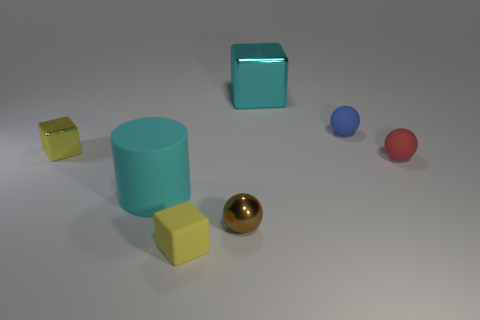Add 2 large cyan objects. How many objects exist? 9 Subtract all small cubes. How many cubes are left? 1 Subtract all green cylinders. How many yellow blocks are left? 2 Subtract all cylinders. How many objects are left? 6 Subtract all yellow cubes. How many cubes are left? 1 Subtract 0 brown cubes. How many objects are left? 7 Subtract 1 cubes. How many cubes are left? 2 Subtract all red cylinders. Subtract all gray balls. How many cylinders are left? 1 Subtract all green metal things. Subtract all tiny yellow metallic cubes. How many objects are left? 6 Add 1 tiny brown metal balls. How many tiny brown metal balls are left? 2 